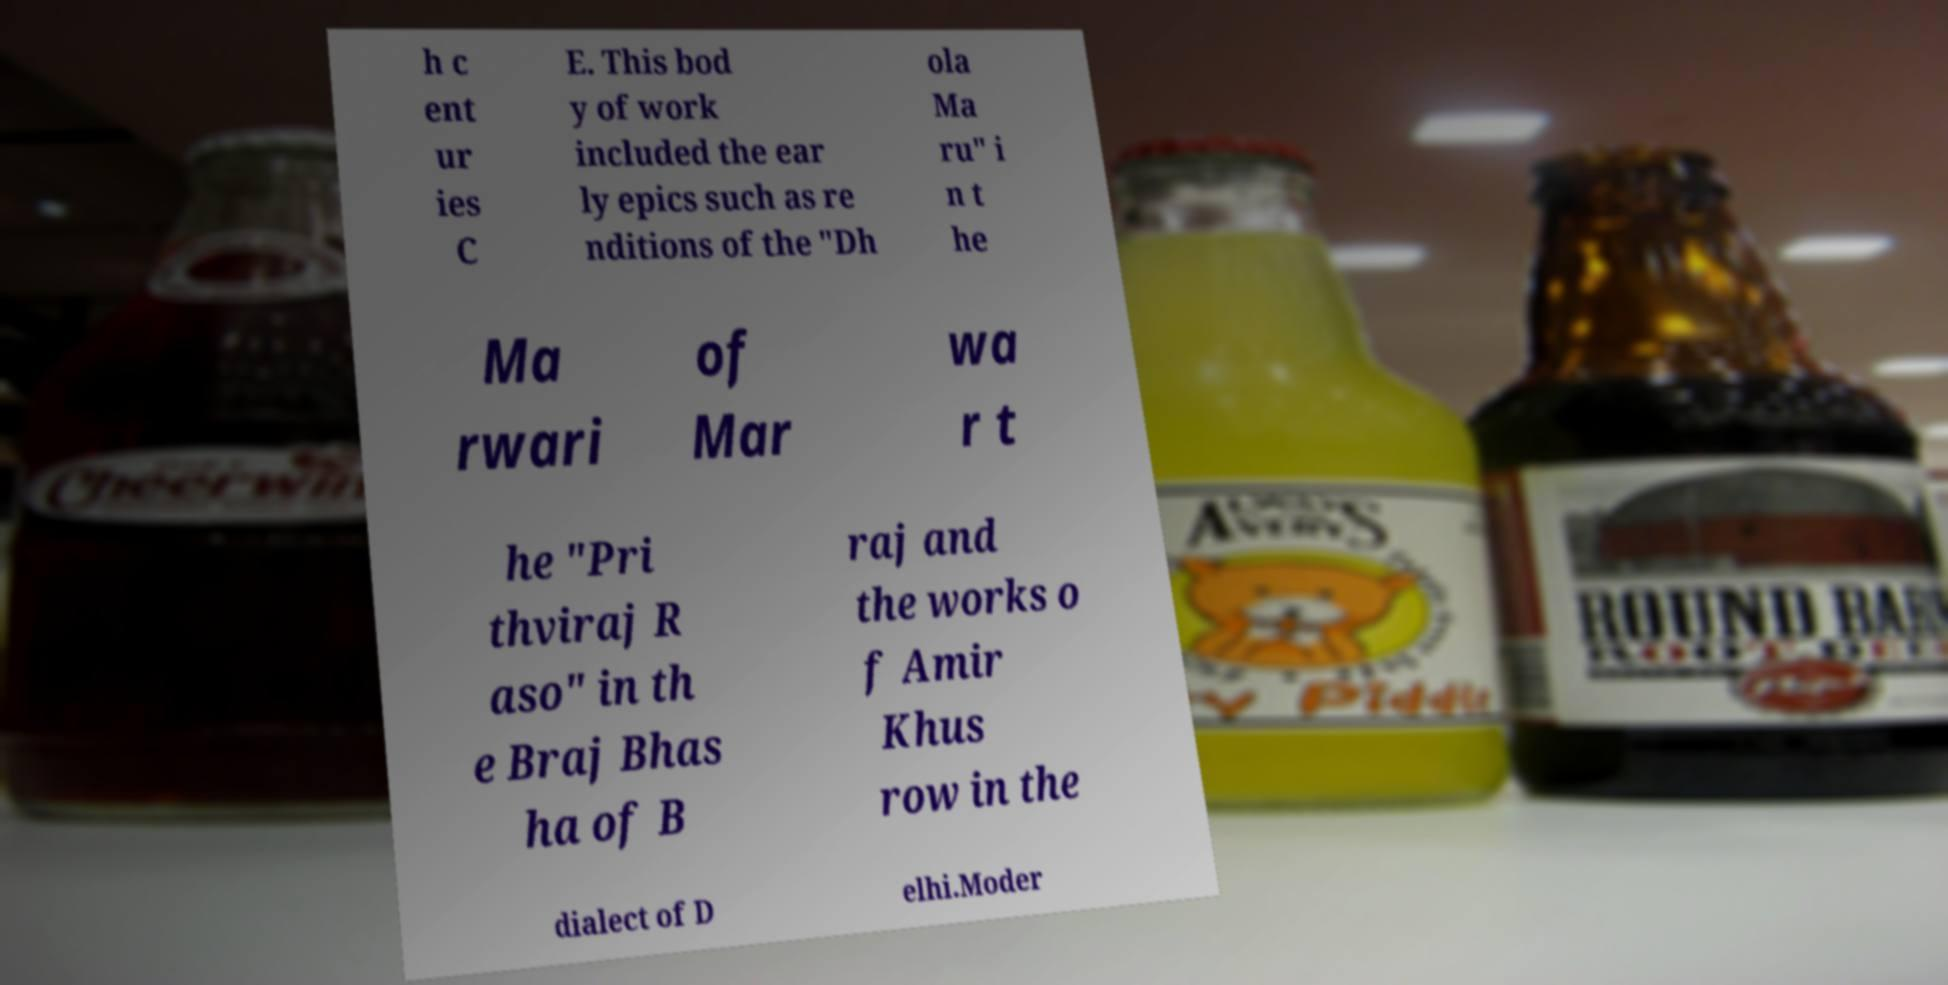Could you extract and type out the text from this image? h c ent ur ies C E. This bod y of work included the ear ly epics such as re nditions of the "Dh ola Ma ru" i n t he Ma rwari of Mar wa r t he "Pri thviraj R aso" in th e Braj Bhas ha of B raj and the works o f Amir Khus row in the dialect of D elhi.Moder 